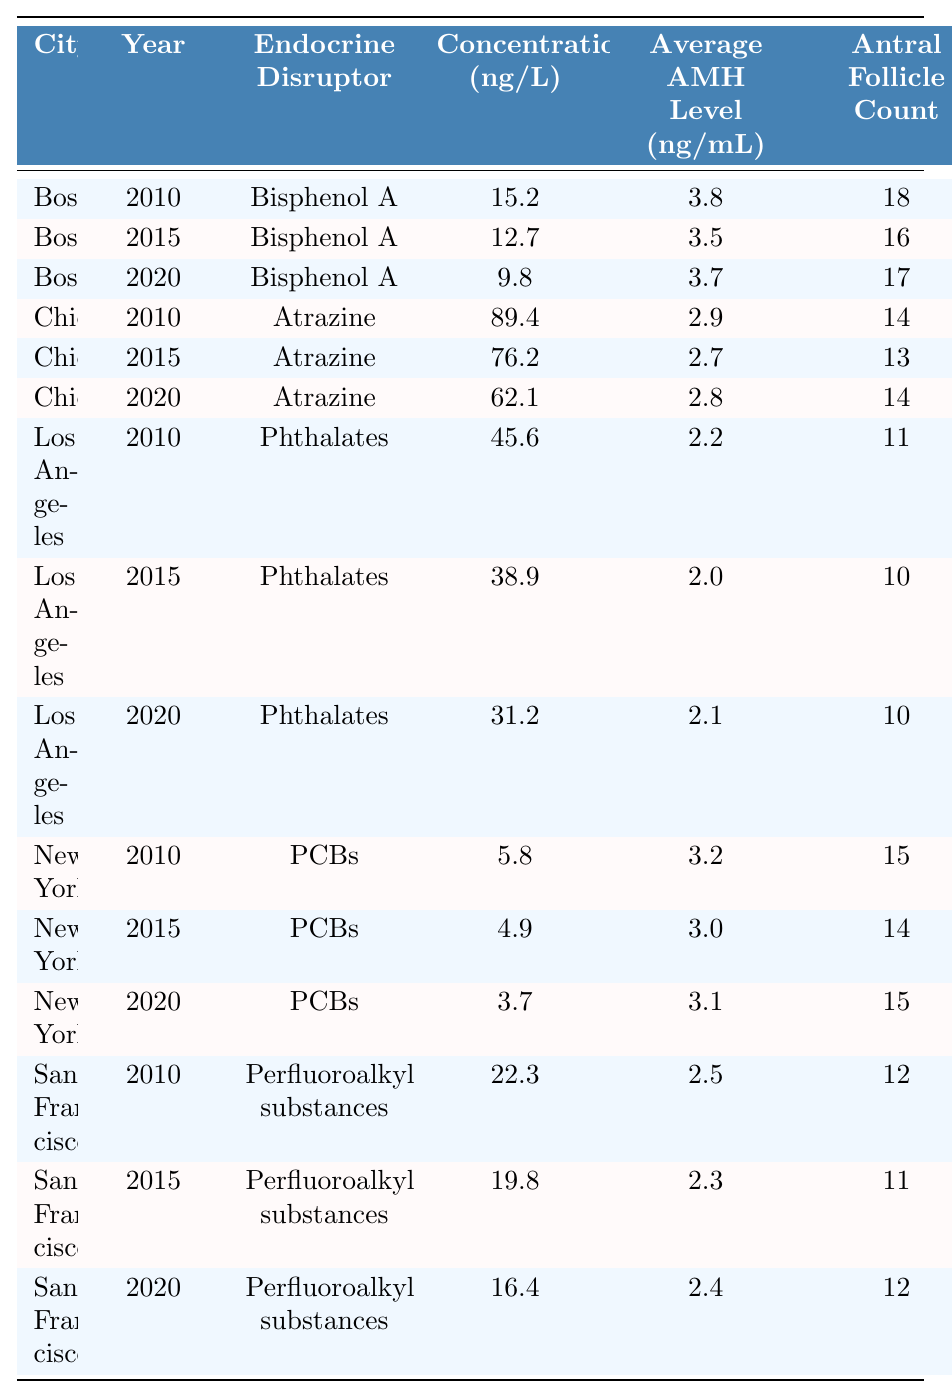What is the concentration of Bisphenol A in Boston in 2020? Referring to the table, the concentration for Bisphenol A in Boston is listed as 9.8 ng/L for the year 2020.
Answer: 9.8 ng/L What age group has the highest Antral Follicle Count recorded? The highest Antral Follicle Count in the table is 18, recorded in Boston for the age group 25-30 in 2010.
Answer: 25-30 What is the average concentration of Atrazine across all years in Chicago? The concentrations for Atrazine in Chicago are 89.4 ng/L (2010), 76.2 ng/L (2015), and 62.1 ng/L (2020). The total is 89.4 + 76.2 + 62.1 = 227.7 ng/L, and dividing by 3 gives an average of 75.9 ng/L.
Answer: 75.9 ng/L Did the Average AMH Level in Los Angeles decrease from 2010 to 2020? In LA, the Average AMH Levels are 2.2 ng/mL (2010), 2.0 ng/mL (2015), and 2.1 ng/mL (2020). The level decreased from 2010 to 2015, but slightly increased in 2020. However, the 2020 level is still below the 2010 level, so yes, it did decrease overall.
Answer: Yes Which city and year had the highest concentration of endocrine disruptors recorded? The highest concentration recorded in the table is for Atrazine in Chicago in 2010, which is 89.4 ng/L.
Answer: Chicago, 2010 What is the difference in Average AMH levels between the age groups 25-30 and 36-40 in New York in 2015? In New York, the Average AMH Level for the age group 25-30 in 2015 is 3.0 ng/mL. The 36-40 age group does not appear in New York for that year, we cannot calculate the difference.
Answer: Not applicable What trend can be observed in the concentration of Phthalates in Los Angeles from 2010 to 2020? The concentrations for Phthalates in Los Angeles are 45.6 ng/L (2010), 38.9 ng/L (2015), and 31.2 ng/L (2020). The trend shows a consistent decrease in concentration over the years.
Answer: Decreasing trend What is the total Antral Follicle Count recorded for the 31-35 age group across all cities? The Antral Follicle Counts for the 31-35 age group are 14 (Chicago, 2010), 13 (Chicago, 2015), 14 (Chicago, 2020), 12 (San Francisco, 2010), 11 (San Francisco, 2015), and 12 (San Francisco, 2020). Adding them: 14 + 13 + 14 + 12 + 11 + 12 = 76.
Answer: 76 Which endocrine disruptor had the lowest concentration in New York across all years? In New York, the concentrations for PCBs are 5.8 ng/L (2010), 4.9 ng/L (2015), and 3.7 ng/L (2020). The lowest concentration is 3.7 ng/L in 2020.
Answer: PCBs, 3.7 ng/L Were the average concentrations of endocrine disruptors in Boston higher or lower than those in Chicago across all years? For Boston, the concentrations of Bisphenol A are 15.2, 12.7, and 9.8 ng/L giving an average of 12.6 ng/L. For Chicago, Atrazine concentrations are higher (89.4, 76.2, and 62.1 ng/L) with an average of 75.9 ng/L. Hence, Chicago's average is higher than Boston's.
Answer: Lower in Boston 